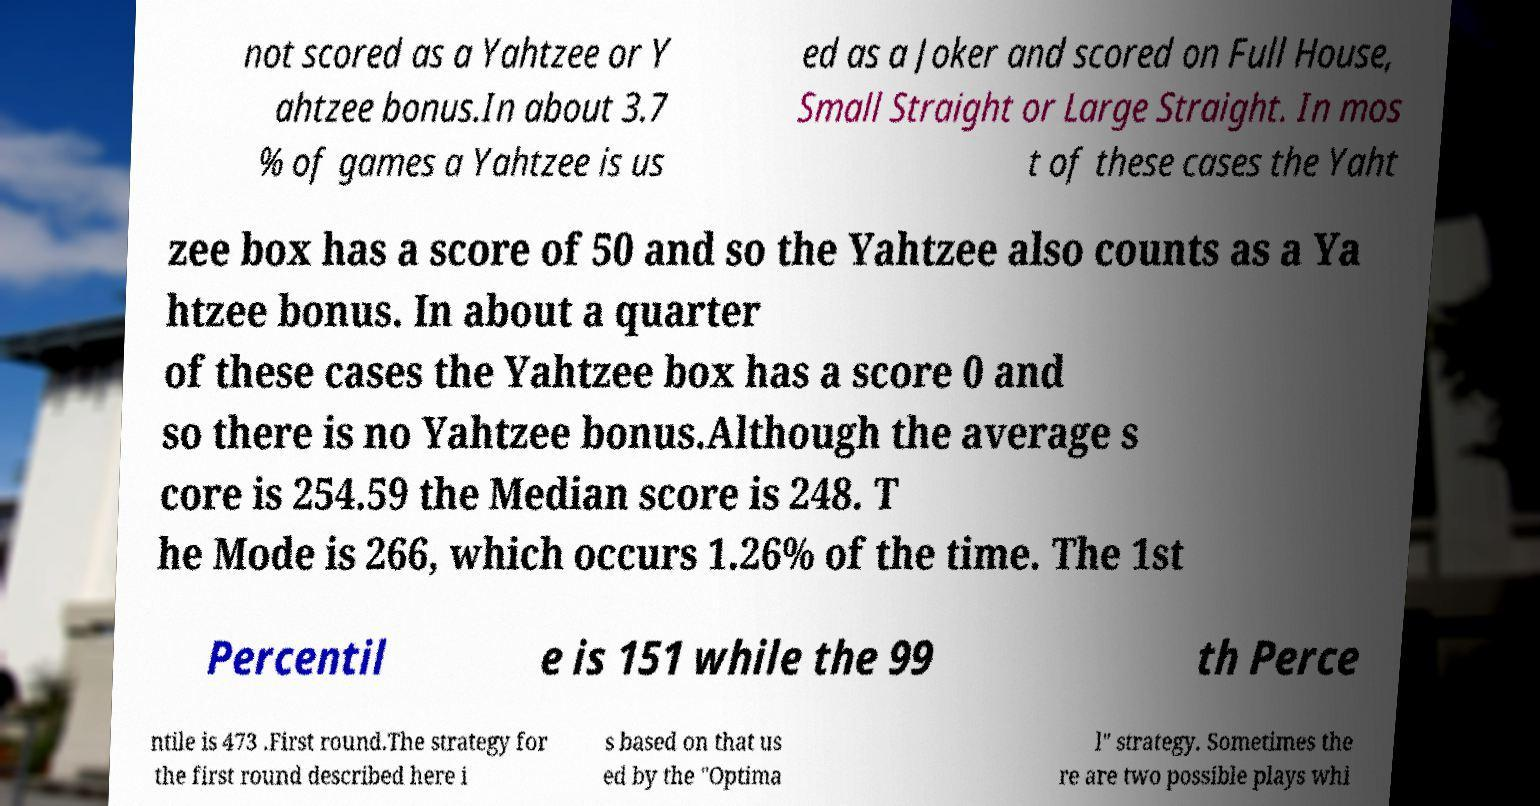What messages or text are displayed in this image? I need them in a readable, typed format. not scored as a Yahtzee or Y ahtzee bonus.In about 3.7 % of games a Yahtzee is us ed as a Joker and scored on Full House, Small Straight or Large Straight. In mos t of these cases the Yaht zee box has a score of 50 and so the Yahtzee also counts as a Ya htzee bonus. In about a quarter of these cases the Yahtzee box has a score 0 and so there is no Yahtzee bonus.Although the average s core is 254.59 the Median score is 248. T he Mode is 266, which occurs 1.26% of the time. The 1st Percentil e is 151 while the 99 th Perce ntile is 473 .First round.The strategy for the first round described here i s based on that us ed by the "Optima l" strategy. Sometimes the re are two possible plays whi 